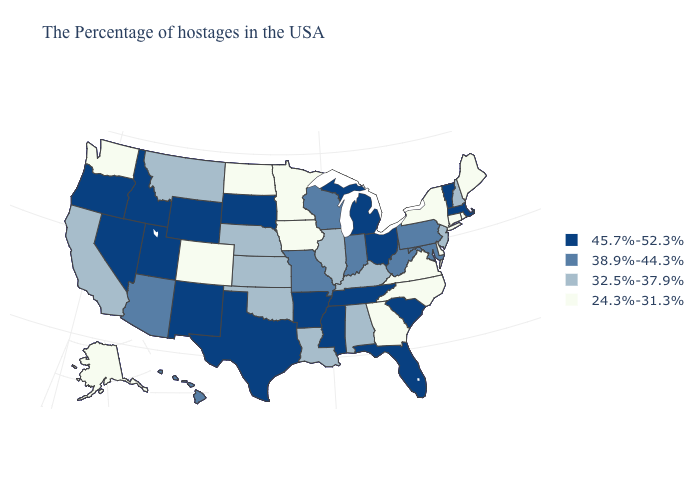Does Ohio have the highest value in the MidWest?
Give a very brief answer. Yes. Name the states that have a value in the range 38.9%-44.3%?
Keep it brief. Maryland, Pennsylvania, West Virginia, Indiana, Wisconsin, Missouri, Arizona, Hawaii. Does Massachusetts have the highest value in the Northeast?
Be succinct. Yes. What is the value of Pennsylvania?
Answer briefly. 38.9%-44.3%. What is the lowest value in the USA?
Give a very brief answer. 24.3%-31.3%. Which states have the highest value in the USA?
Write a very short answer. Massachusetts, Vermont, South Carolina, Ohio, Florida, Michigan, Tennessee, Mississippi, Arkansas, Texas, South Dakota, Wyoming, New Mexico, Utah, Idaho, Nevada, Oregon. Among the states that border New Jersey , does Delaware have the lowest value?
Be succinct. Yes. Does Pennsylvania have the lowest value in the Northeast?
Give a very brief answer. No. Name the states that have a value in the range 38.9%-44.3%?
Be succinct. Maryland, Pennsylvania, West Virginia, Indiana, Wisconsin, Missouri, Arizona, Hawaii. Name the states that have a value in the range 24.3%-31.3%?
Give a very brief answer. Maine, Rhode Island, Connecticut, New York, Delaware, Virginia, North Carolina, Georgia, Minnesota, Iowa, North Dakota, Colorado, Washington, Alaska. Does West Virginia have the highest value in the USA?
Write a very short answer. No. Name the states that have a value in the range 24.3%-31.3%?
Be succinct. Maine, Rhode Island, Connecticut, New York, Delaware, Virginia, North Carolina, Georgia, Minnesota, Iowa, North Dakota, Colorado, Washington, Alaska. Does New Mexico have a higher value than Hawaii?
Write a very short answer. Yes. What is the lowest value in states that border Montana?
Answer briefly. 24.3%-31.3%. What is the value of Louisiana?
Short answer required. 32.5%-37.9%. 